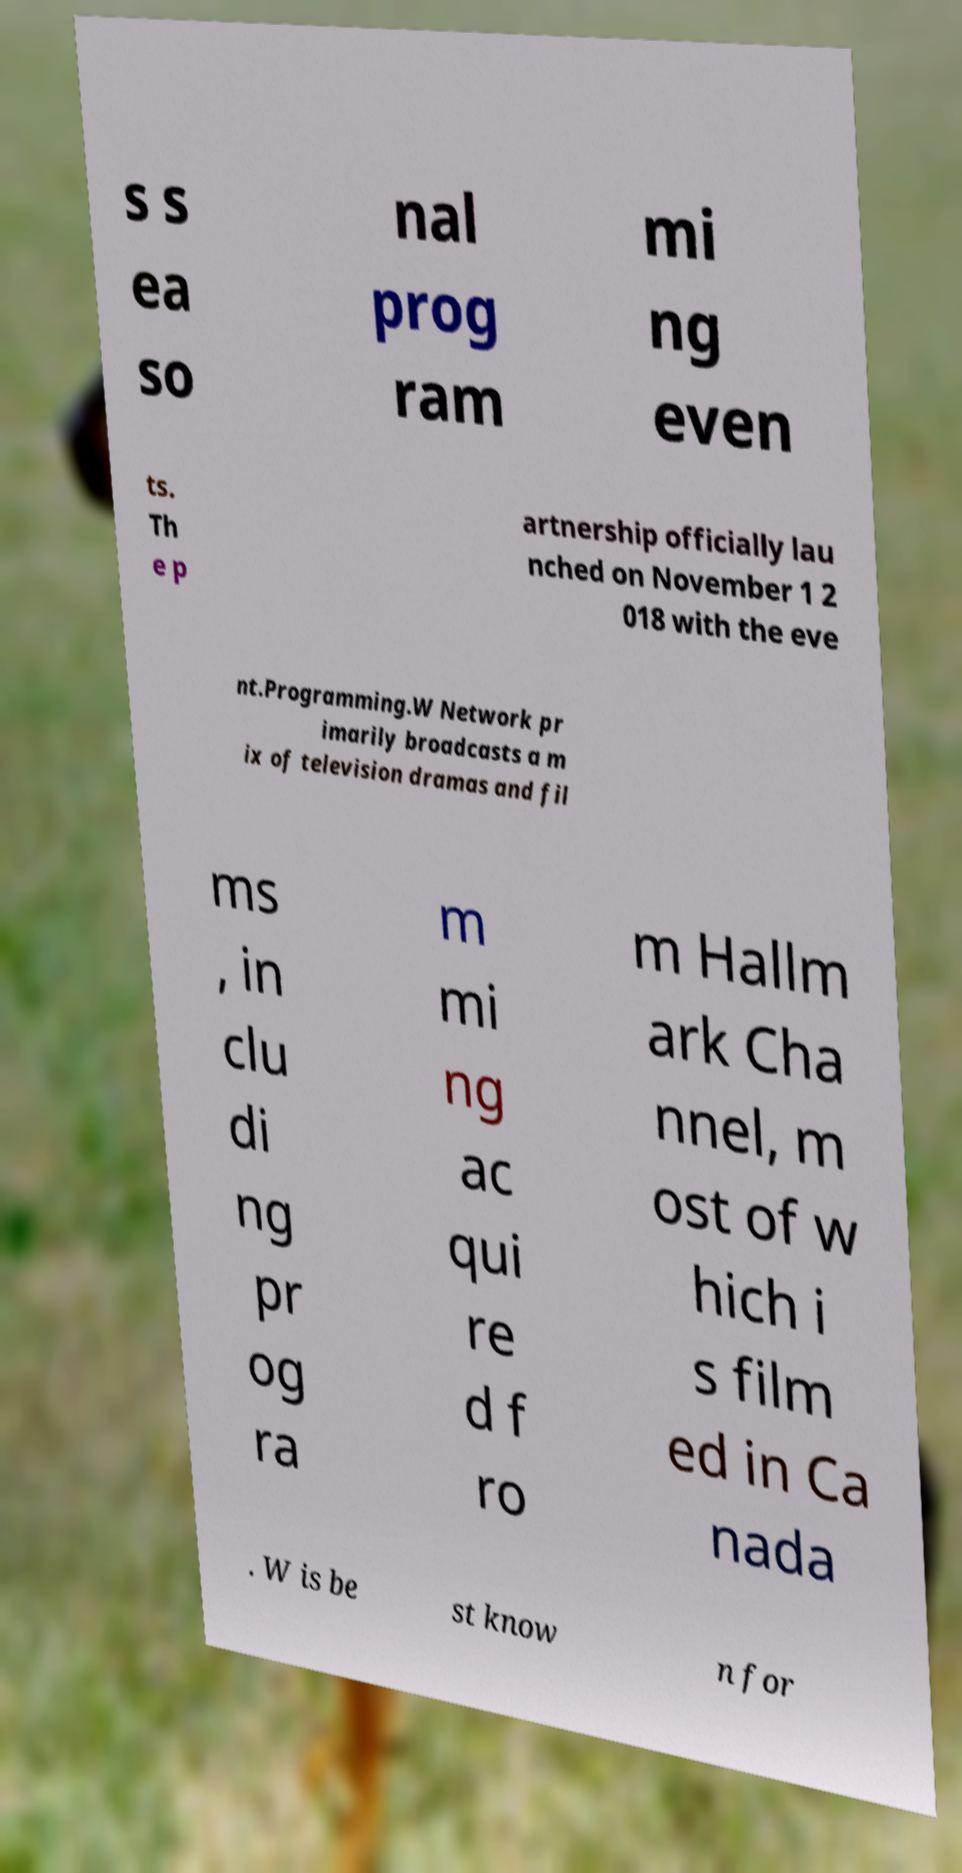What messages or text are displayed in this image? I need them in a readable, typed format. s s ea so nal prog ram mi ng even ts. Th e p artnership officially lau nched on November 1 2 018 with the eve nt.Programming.W Network pr imarily broadcasts a m ix of television dramas and fil ms , in clu di ng pr og ra m mi ng ac qui re d f ro m Hallm ark Cha nnel, m ost of w hich i s film ed in Ca nada . W is be st know n for 